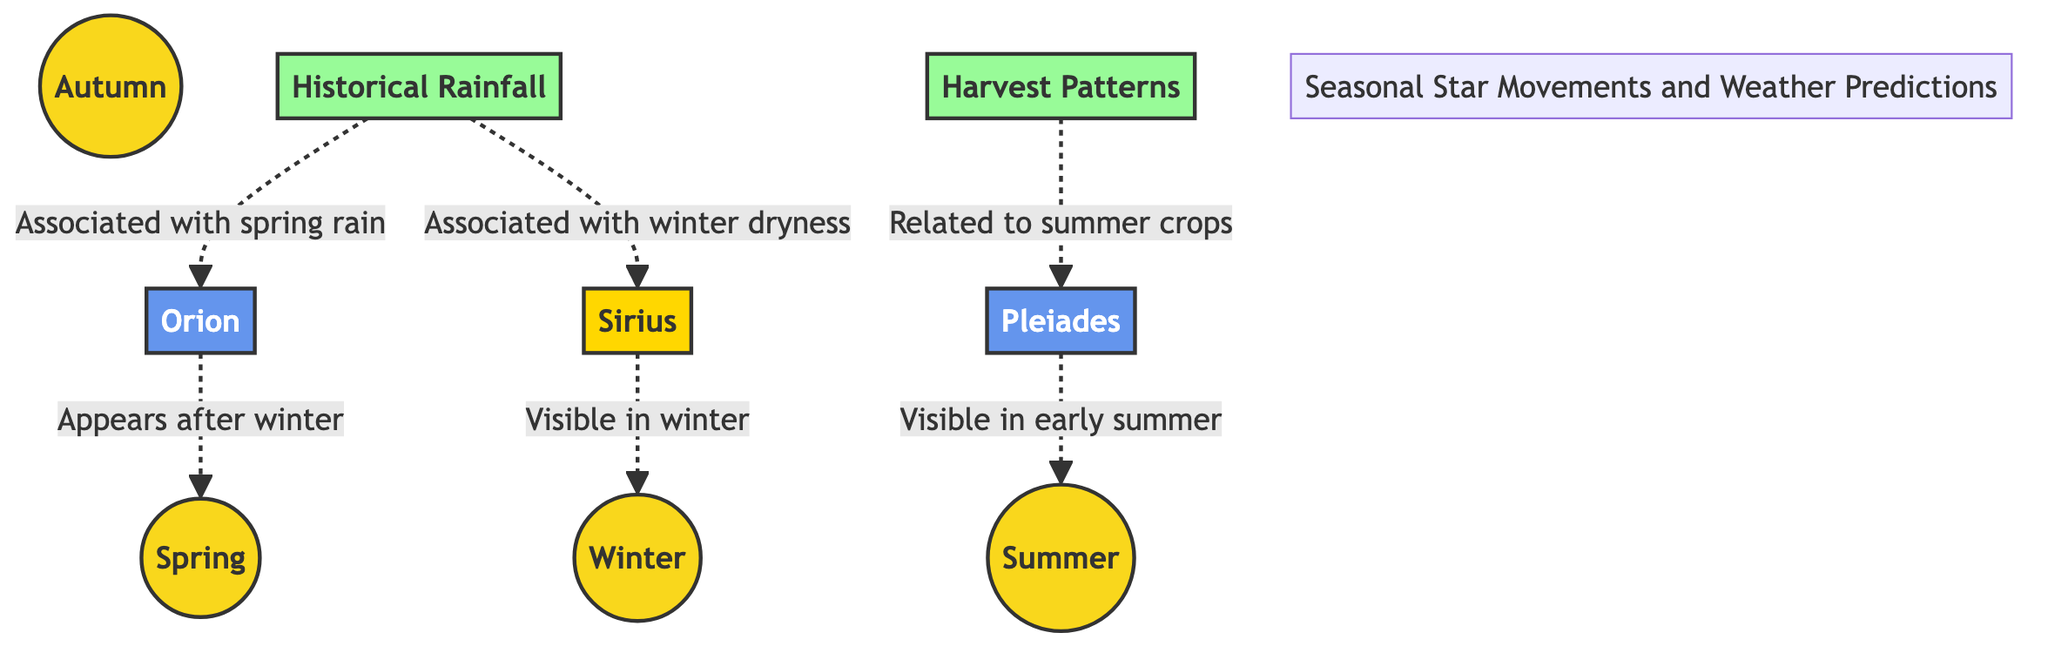What are the four seasons depicted in the diagram? The diagram includes four distinct nodes labeled as Spring, Summer, Autumn, and Winter, which are the primary seasonal divisions.
Answer: Spring, Summer, Autumn, Winter Which constellation appears after winter? According to the diagram, the line indicates that Orion appears after winter, directly connecting it to Spring.
Answer: Orion How many stars are represented in this chart? The diagram represents two celestial entities specifically categorized as stars: Sirius and Pleiades, totaling two.
Answer: 2 What weather phenomenon is associated with Orion? The diagram states that historical rainfall (HR) is associated with spring rain, which is linked to the appearance of Orion, making it the pertinent answer.
Answer: Spring rain Which season is the Pleiades associated with? The diagram shows that Pleiades is specifically noted as visible in early summer, linking it directly with that season.
Answer: Summer What is the weather impact of Sirius during winter? The diagram indicates that Sirius is associated with winter dryness, implying its influence on weather patterns during this season.
Answer: Winter dryness How are harvest patterns related to the Pleiades? The diagram connects harvest patterns (HP) specifically to summer crops, indicating that the appearance of Pleiades is directly related to this agricultural phenomenon.
Answer: Related to summer crops What links Sirius and Orion to weather predictions? The diagram shows a connection where Sirius is associated with winter dryness and Orion with spring rain, establishing their relevance in weather prediction.
Answer: Winter dryness, spring rain 